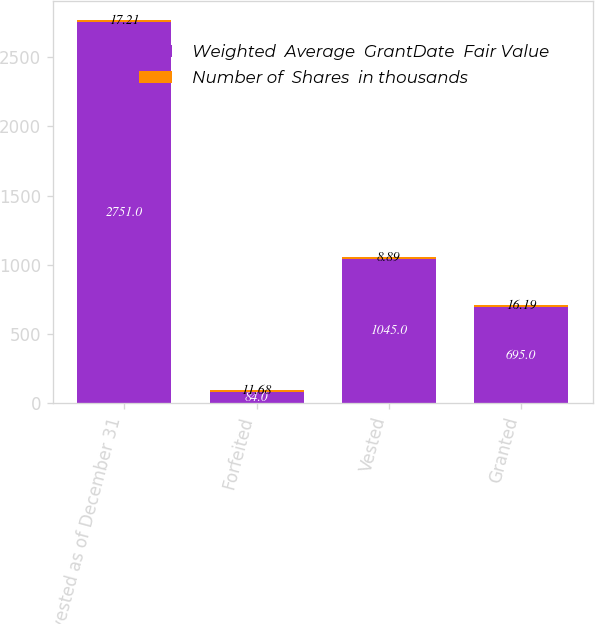Convert chart to OTSL. <chart><loc_0><loc_0><loc_500><loc_500><stacked_bar_chart><ecel><fcel>Unvested as of December 31<fcel>Forfeited<fcel>Vested<fcel>Granted<nl><fcel>Weighted  Average  GrantDate  Fair Value<fcel>2751<fcel>84<fcel>1045<fcel>695<nl><fcel>Number of  Shares  in thousands<fcel>17.21<fcel>11.68<fcel>8.89<fcel>16.19<nl></chart> 